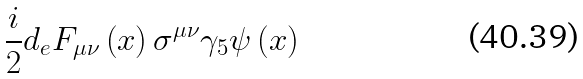Convert formula to latex. <formula><loc_0><loc_0><loc_500><loc_500>\frac { i } { 2 } d _ { e } F _ { \mu \nu } \left ( x \right ) \sigma ^ { \mu \nu } \gamma _ { 5 } \psi \left ( x \right )</formula> 